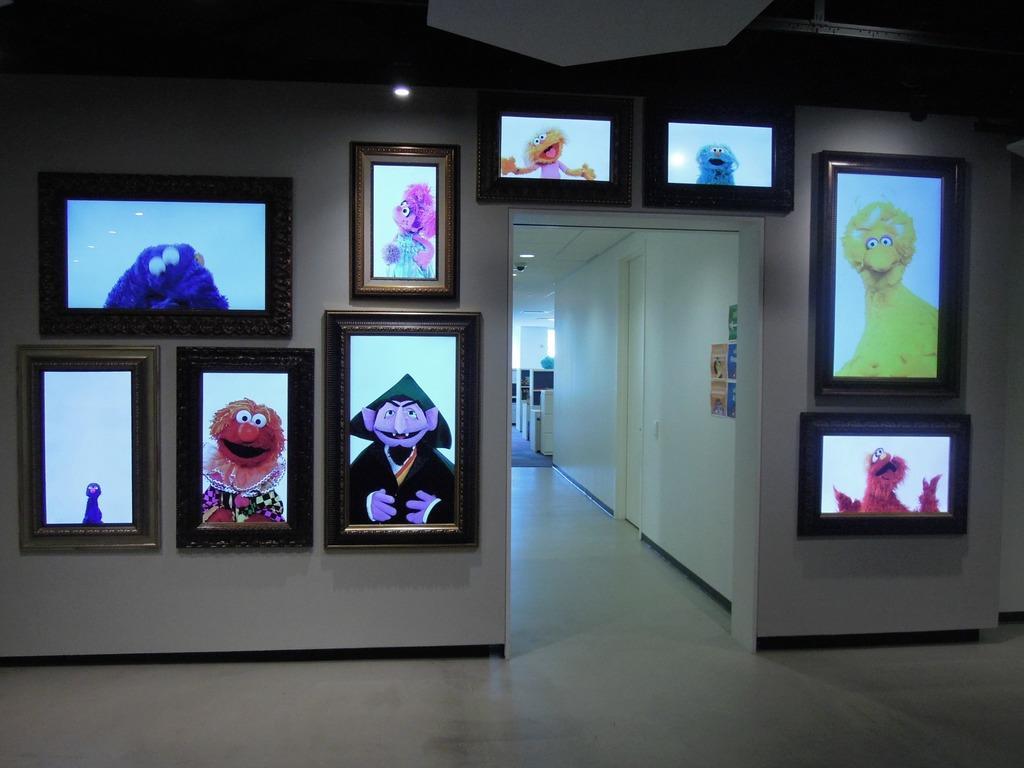How would you summarize this image in a sentence or two? In this image we can see some frames attached to a wall. We can also see some papers pasted on a wall, a door and some ceiling lights to a roof. 